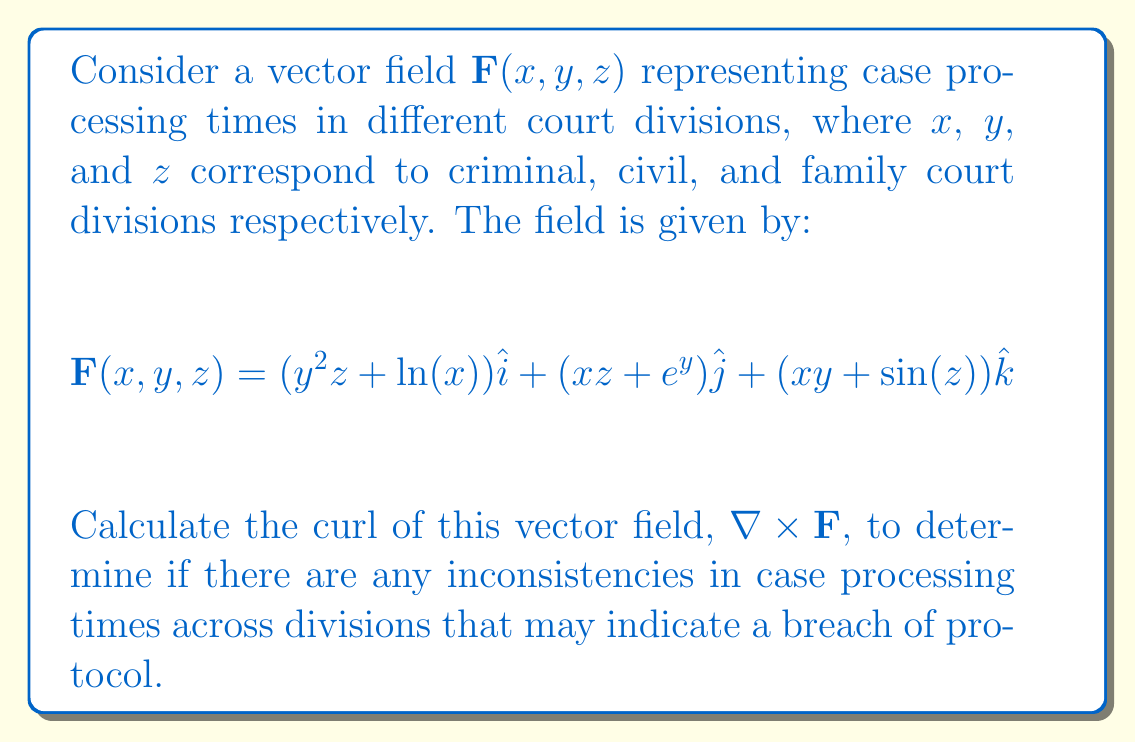Show me your answer to this math problem. To find the curl of the vector field, we need to calculate $\nabla \times \mathbf{F}$. The curl in 3D Cartesian coordinates is given by:

$$\nabla \times \mathbf{F} = \left(\frac{\partial F_z}{\partial y} - \frac{\partial F_y}{\partial z}\right)\hat{i} + \left(\frac{\partial F_x}{\partial z} - \frac{\partial F_z}{\partial x}\right)\hat{j} + \left(\frac{\partial F_y}{\partial x} - \frac{\partial F_x}{\partial y}\right)\hat{k}$$

Let's calculate each component:

1. $\hat{i}$ component:
   $\frac{\partial F_z}{\partial y} = x$
   $\frac{\partial F_y}{\partial z} = x$
   $\frac{\partial F_z}{\partial y} - \frac{\partial F_y}{\partial z} = x - x = 0$

2. $\hat{j}$ component:
   $\frac{\partial F_x}{\partial z} = y^2$
   $\frac{\partial F_z}{\partial x} = y$
   $\frac{\partial F_x}{\partial z} - \frac{\partial F_z}{\partial x} = y^2 - y = y^2 - y$

3. $\hat{k}$ component:
   $\frac{\partial F_y}{\partial x} = z$
   $\frac{\partial F_x}{\partial y} = 2yz$
   $\frac{\partial F_y}{\partial x} - \frac{\partial F_x}{\partial y} = z - 2yz = z(1-2y)$

Therefore, the curl of the vector field is:

$$\nabla \times \mathbf{F} = 0\hat{i} + (y^2 - y)\hat{j} + z(1-2y)\hat{k}$$

This result indicates potential inconsistencies in case processing times between divisions, which may warrant further investigation for possible breaches in protocol.
Answer: $$\nabla \times \mathbf{F} = 0\hat{i} + (y^2 - y)\hat{j} + z(1-2y)\hat{k}$$ 